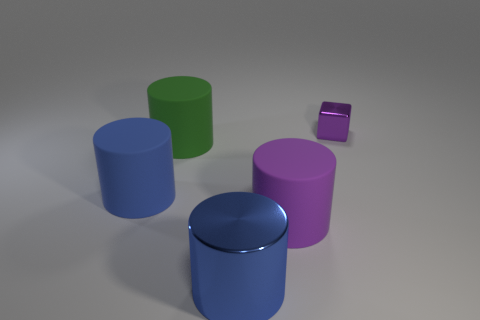There is a big thing that is the same color as the tiny thing; what is its material?
Your answer should be very brief. Rubber. What size is the cylinder that is the same color as the metal block?
Your answer should be compact. Large. Is there a large matte cylinder that has the same color as the small thing?
Offer a terse response. Yes. There is a blue cylinder in front of the blue rubber cylinder; is it the same size as the small shiny block?
Keep it short and to the point. No. How many blue objects are both in front of the big purple matte thing and to the left of the large green cylinder?
Provide a short and direct response. 0. There is a blue thing in front of the purple object that is to the left of the purple cube; what is its size?
Your answer should be compact. Large. Are there fewer rubber things that are in front of the blue metallic thing than purple blocks that are in front of the metallic block?
Make the answer very short. No. There is a object that is in front of the purple matte object; is it the same color as the matte cylinder that is left of the large green matte cylinder?
Your answer should be compact. Yes. There is a thing that is both behind the large purple rubber cylinder and right of the big blue shiny thing; what material is it made of?
Make the answer very short. Metal. Are any rubber things visible?
Offer a terse response. Yes. 